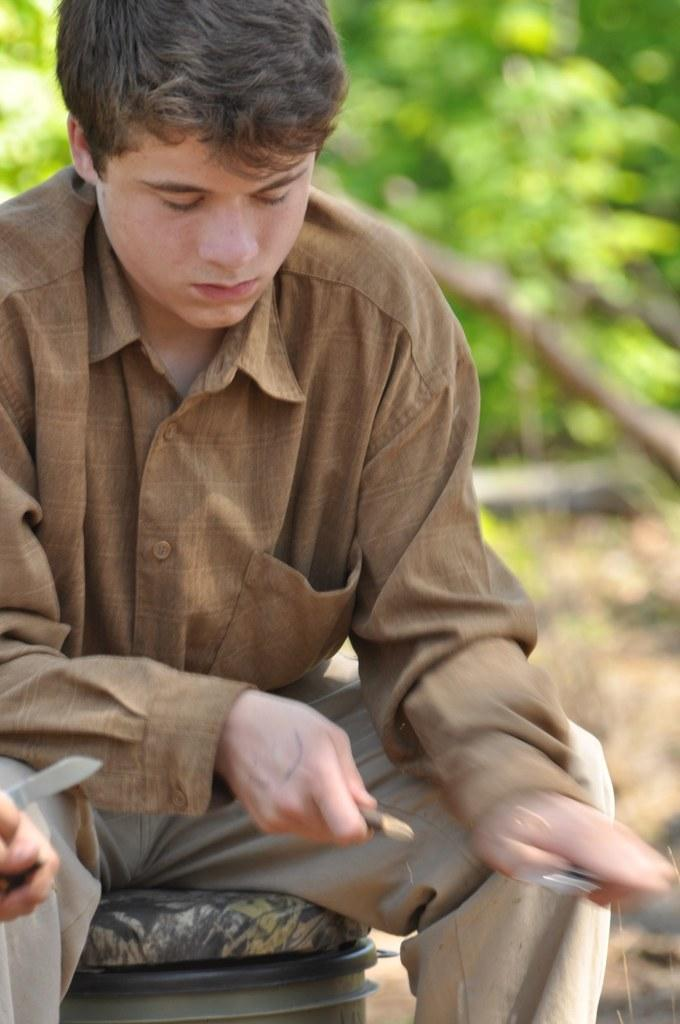What is the main subject of the image? There is a man sitting in the middle of the image. What is the man holding in the image? The man is holding something. What can be seen in the background of the image? There are trees visible behind the man. What type of writing can be seen in the notebook the man is holding in the image? There is no notebook present in the image, and therefore no writing can be observed. 